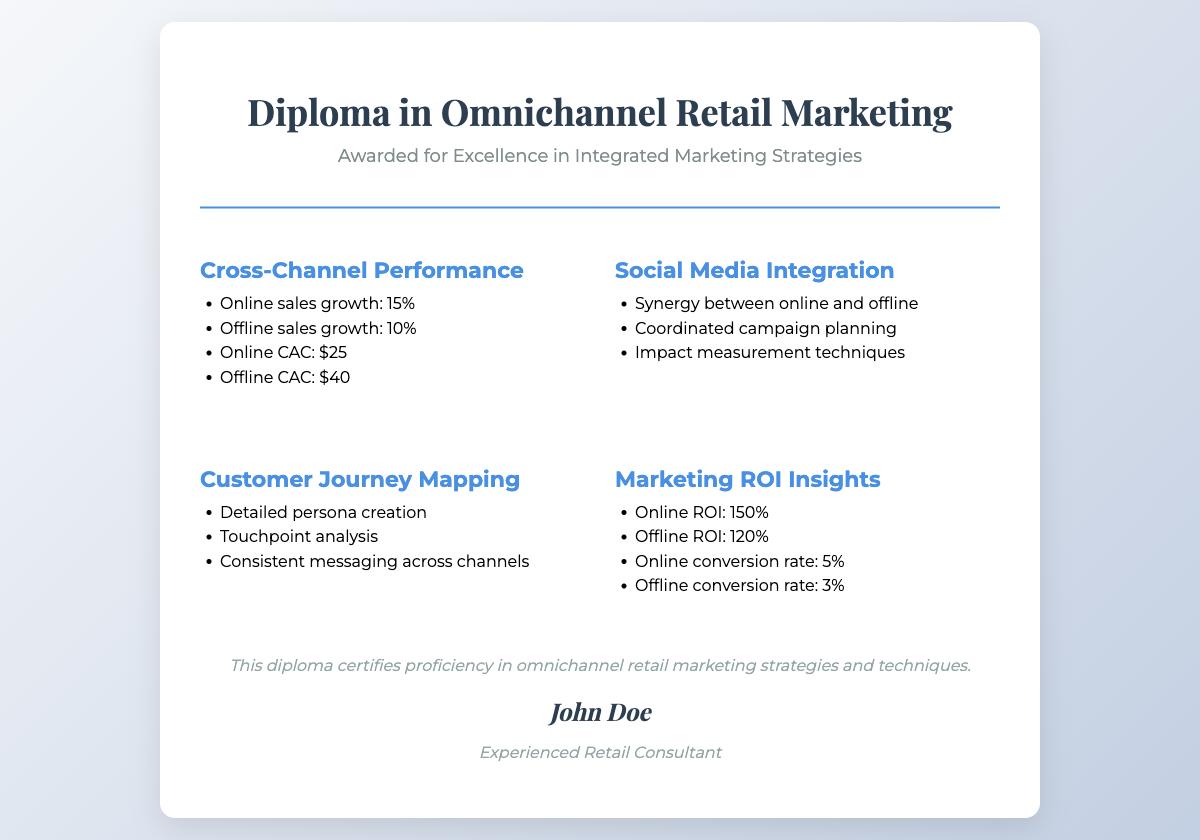what is the online sales growth percentage? The online sales growth percentage is mentioned in the section on Cross-Channel Performance, which states that online sales growth is 15%.
Answer: 15% what is the offline customer acquisition cost? The offline customer acquisition cost is detailed in the Cross-Channel Performance section as $40.
Answer: $40 what are the online and offline ROIs? The document provides the online ROI as 150% and the offline ROI as 120%, and these are found in the Marketing ROI Insights section.
Answer: 150% and 120% how are the social media campaigns characterized in the document? The Social Media Integration section lists key elements such as synergy between online and offline and coordinated campaign planning, indicating the integration's nature.
Answer: Synergy and coordinated planning what method is suggested for analyzing customer touchpoints? The Customer Journey Mapping section mentions touchpoint analysis as a technique for analyzing customer interactions, indicating a systematic approach.
Answer: Touchpoint analysis 